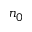<formula> <loc_0><loc_0><loc_500><loc_500>n _ { 0 }</formula> 